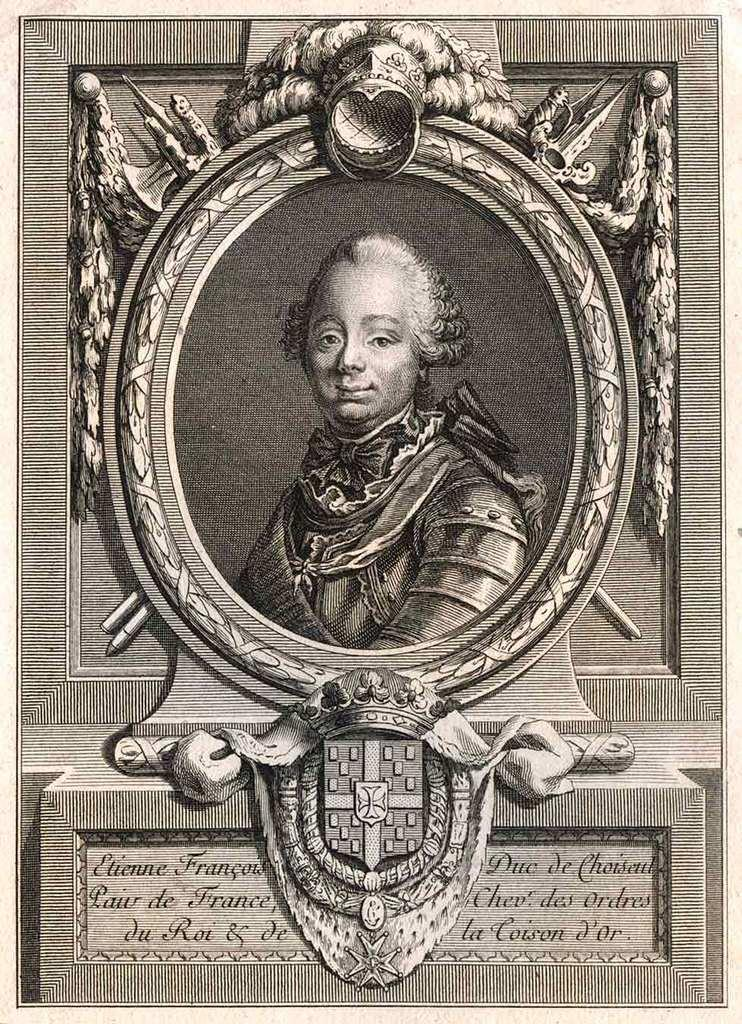<image>
Create a compact narrative representing the image presented. a fancy print of a young boy reads Etienne Francois 